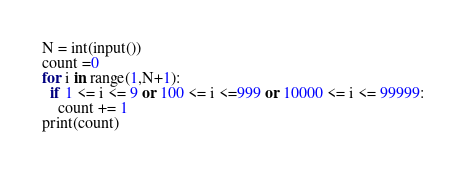<code> <loc_0><loc_0><loc_500><loc_500><_Python_>N = int(input())
count =0
for i in range(1,N+1):
  if 1 <= i <= 9 or 100 <= i <=999 or 10000 <= i <= 99999:
    count += 1
print(count)</code> 